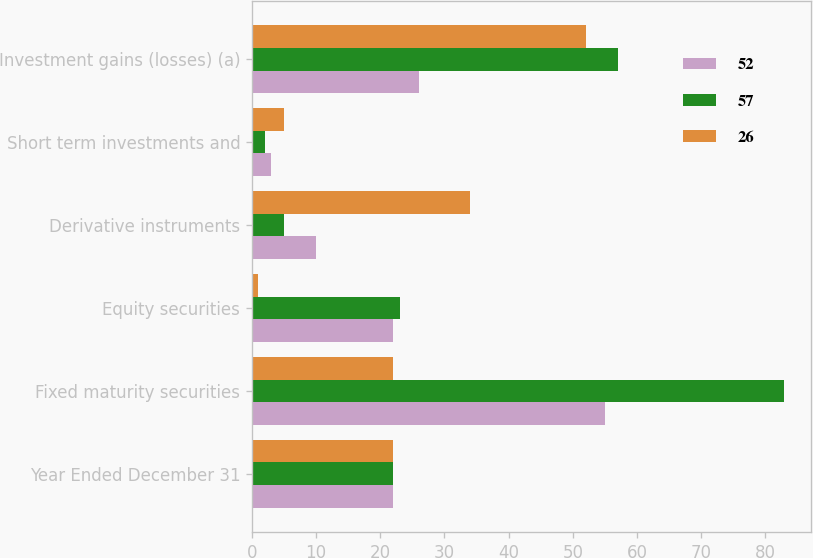Convert chart. <chart><loc_0><loc_0><loc_500><loc_500><stacked_bar_chart><ecel><fcel>Year Ended December 31<fcel>Fixed maturity securities<fcel>Equity securities<fcel>Derivative instruments<fcel>Short term investments and<fcel>Investment gains (losses) (a)<nl><fcel>52<fcel>22<fcel>55<fcel>22<fcel>10<fcel>3<fcel>26<nl><fcel>57<fcel>22<fcel>83<fcel>23<fcel>5<fcel>2<fcel>57<nl><fcel>26<fcel>22<fcel>22<fcel>1<fcel>34<fcel>5<fcel>52<nl></chart> 